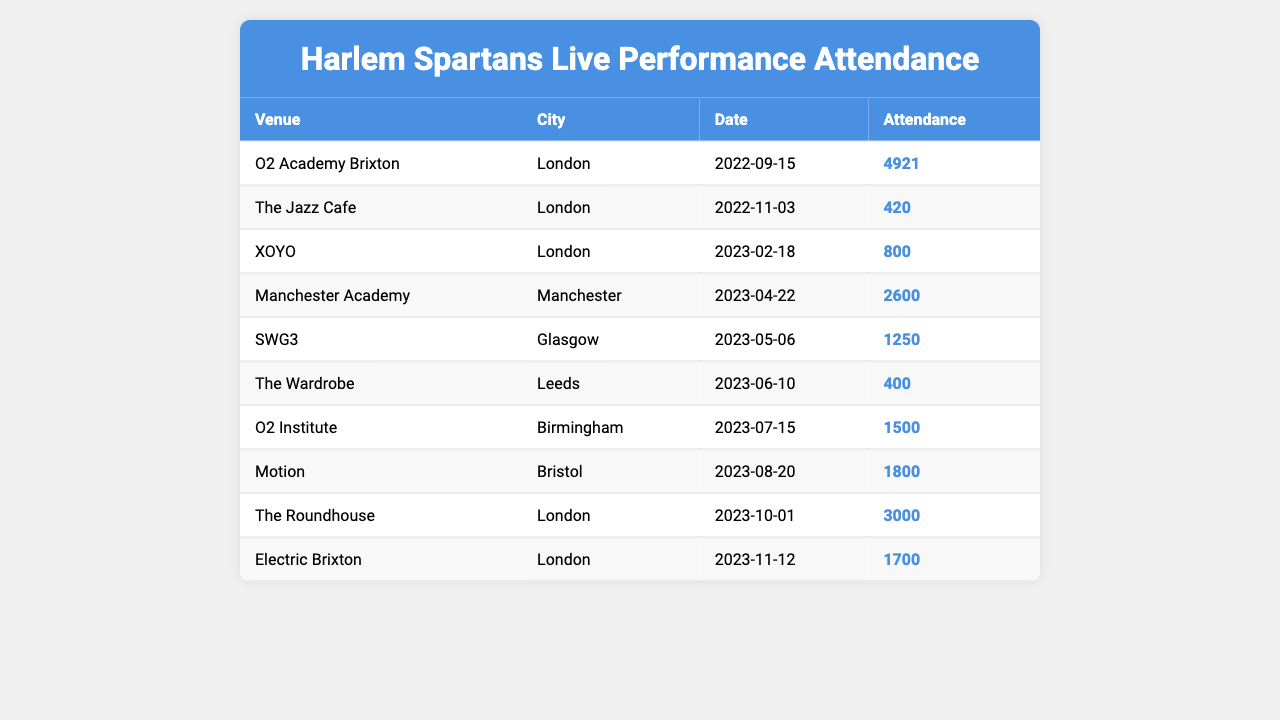What was the highest attendance at a Harlem Spartans' performance? By reviewing the attendance figures in the table, the highest number is 4921 from the performance at O2 Academy Brixton on September 15, 2022.
Answer: 4921 Which city hosted the performance with the lowest attendance? The lowest attendance is 400, which occurred at The Wardrobe in Leeds on June 10, 2023.
Answer: Leeds How many performances took place in London? Counting the entries in the table, there are 5 performances recorded in London: O2 Academy Brixton, The Jazz Cafe, XOYO, The Roundhouse, and Electric Brixton.
Answer: 5 What is the total attendance for all performances listed? Adding up the attendance figures: 4921 + 420 + 800 + 2600 + 1250 + 400 + 1500 + 1800 + 3000 + 1700 equals 16,091.
Answer: 16091 Did any performance have an attendance of over 3000? Checking the attendance figures, the highest number is 4921, which is over 3000, confirming there was a performance with such attendance.
Answer: Yes Which venue had more attendance: Motion or SWG3? Looking at the attendance figures, Motion had 1800 while SWG3 had 1250, so Motion had higher attendance.
Answer: Motion What is the average attendance of the performances held in Birmingham and Glasgow? Birmingham's attendance was 1500, and Glasgow's was 1250. The average is (1500 + 1250) / 2 = 1375.
Answer: 1375 How many attendees were there in total for all performances outside of London? Adding the figures for Manchester (2600), Glasgow (1250), Leeds (400), Birmingham (1500), and Bristol (1800): 2600 + 1250 + 400 + 1500 + 1800 equals 7,550.
Answer: 7550 Was there a performance on November 12, 2023? The table shows an entry for Electric Brixton on that date with an attendance of 1700, confirming a performance took place.
Answer: Yes Which venue had the attendance closest to the average attendance of all performances? The average attendance is 16091 / 10 = 1609.1. The closest attendance is 1500 at O2 Institute.
Answer: O2 Institute 